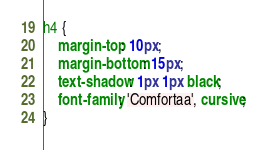Convert code to text. <code><loc_0><loc_0><loc_500><loc_500><_CSS_>h4 {
    margin-top: 10px;
    margin-bottom: 15px;
    text-shadow: 1px 1px black;
    font-family: 'Comfortaa', cursive;
}
</code> 